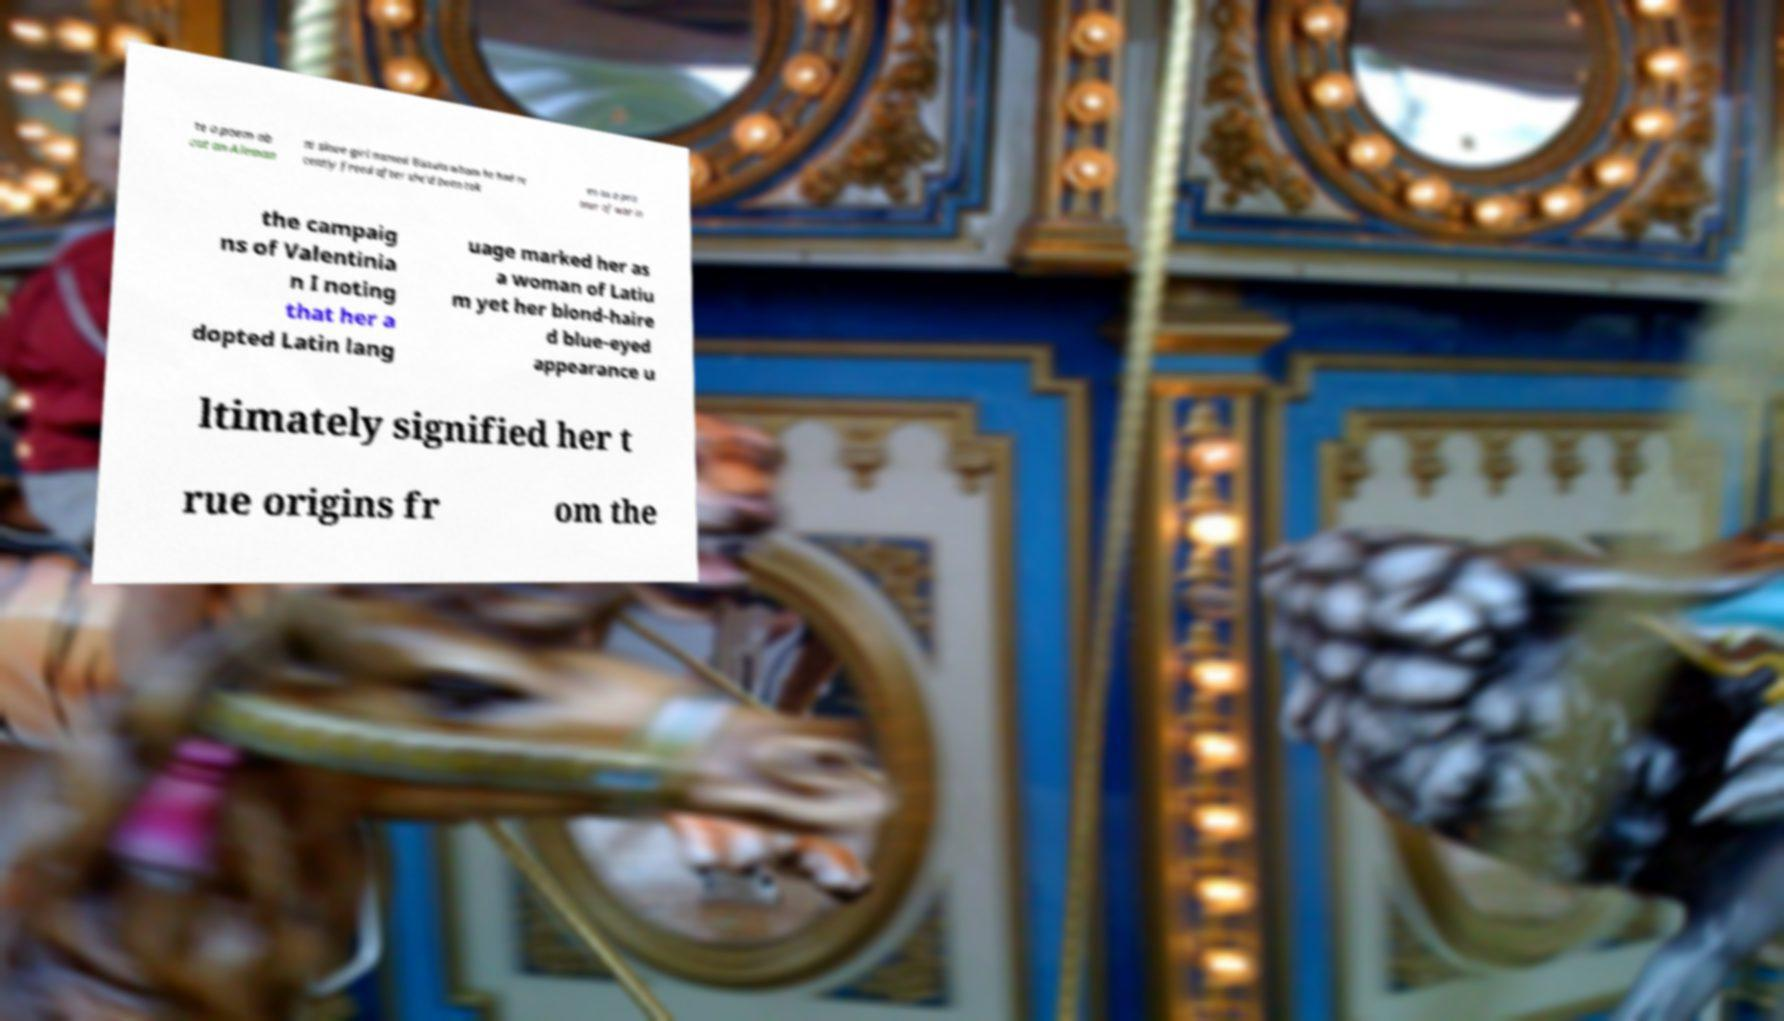For documentation purposes, I need the text within this image transcribed. Could you provide that? te a poem ab out an Aleman ni slave girl named Bissula whom he had re cently freed after she'd been tak en as a pris oner of war in the campaig ns of Valentinia n I noting that her a dopted Latin lang uage marked her as a woman of Latiu m yet her blond-haire d blue-eyed appearance u ltimately signified her t rue origins fr om the 